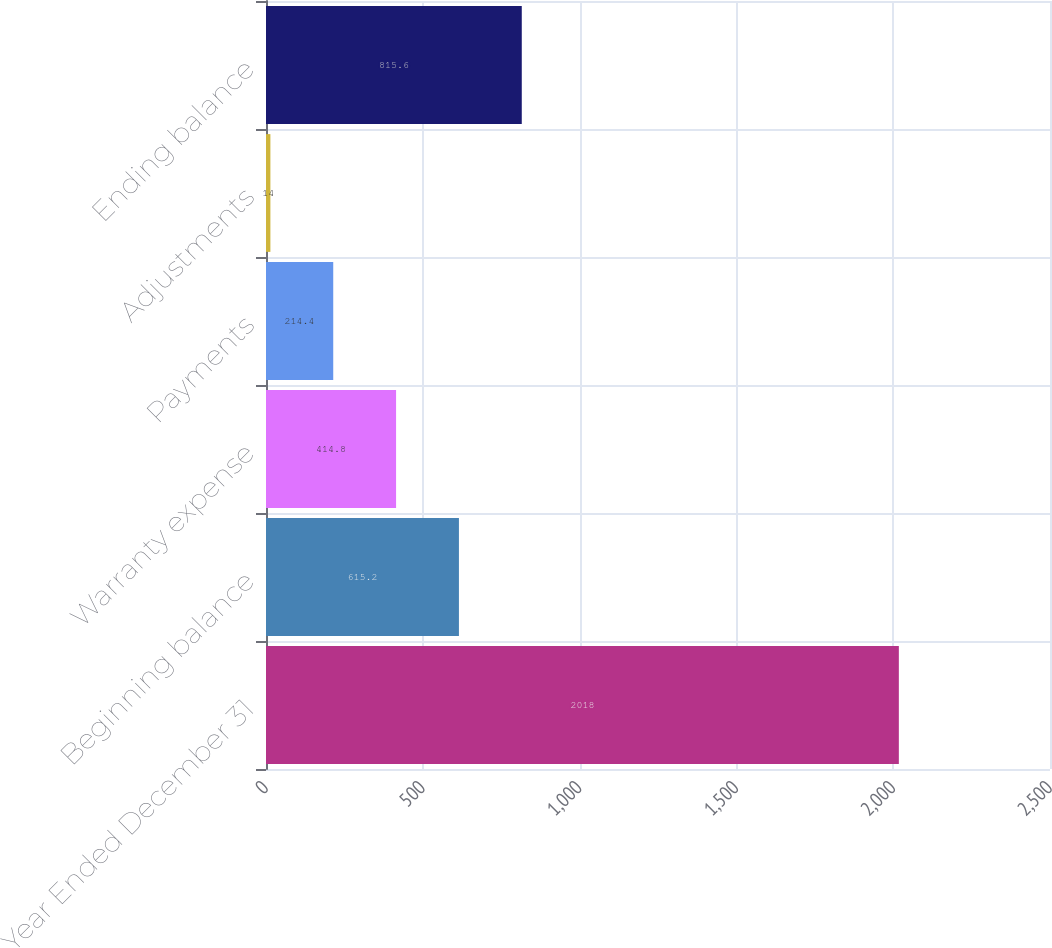Convert chart to OTSL. <chart><loc_0><loc_0><loc_500><loc_500><bar_chart><fcel>Year Ended December 31<fcel>Beginning balance<fcel>Warranty expense<fcel>Payments<fcel>Adjustments<fcel>Ending balance<nl><fcel>2018<fcel>615.2<fcel>414.8<fcel>214.4<fcel>14<fcel>815.6<nl></chart> 